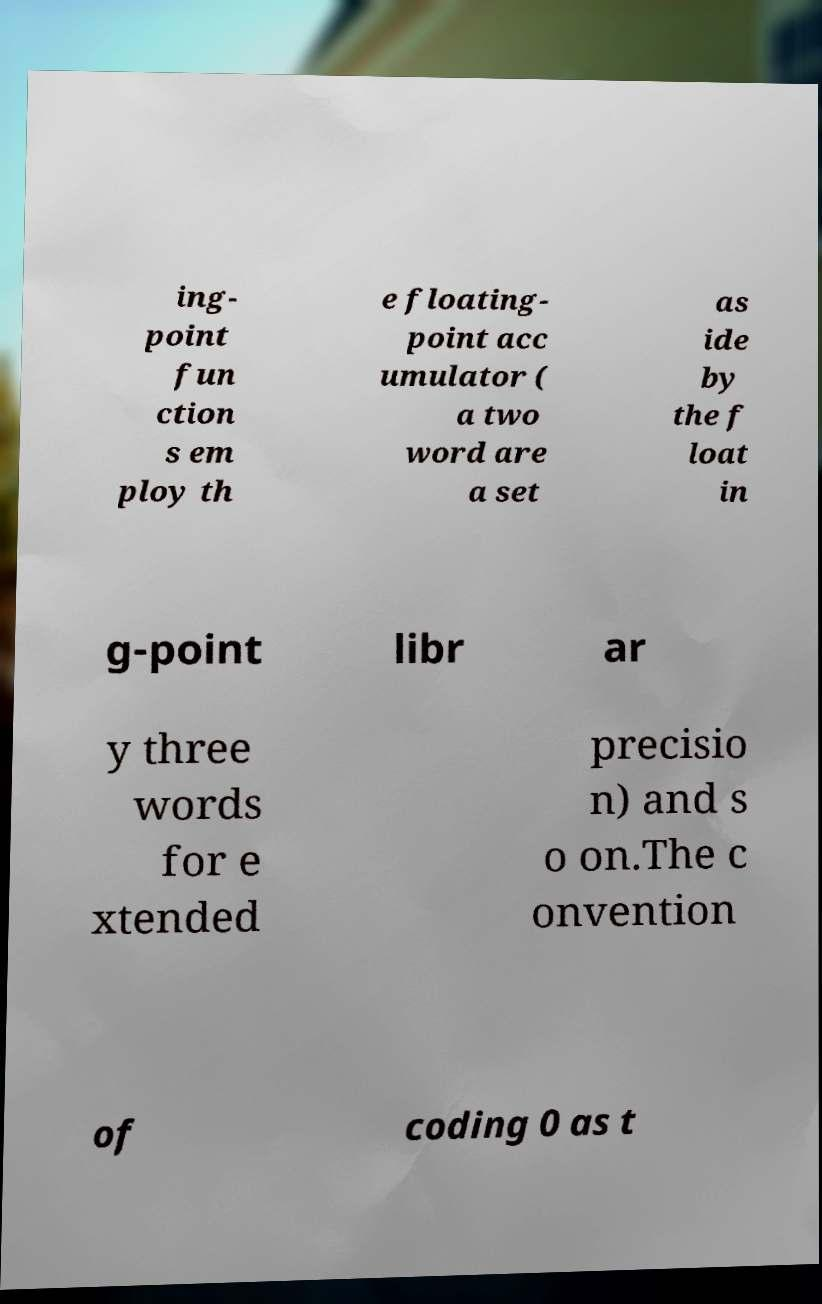Please read and relay the text visible in this image. What does it say? ing- point fun ction s em ploy th e floating- point acc umulator ( a two word are a set as ide by the f loat in g-point libr ar y three words for e xtended precisio n) and s o on.The c onvention of coding 0 as t 